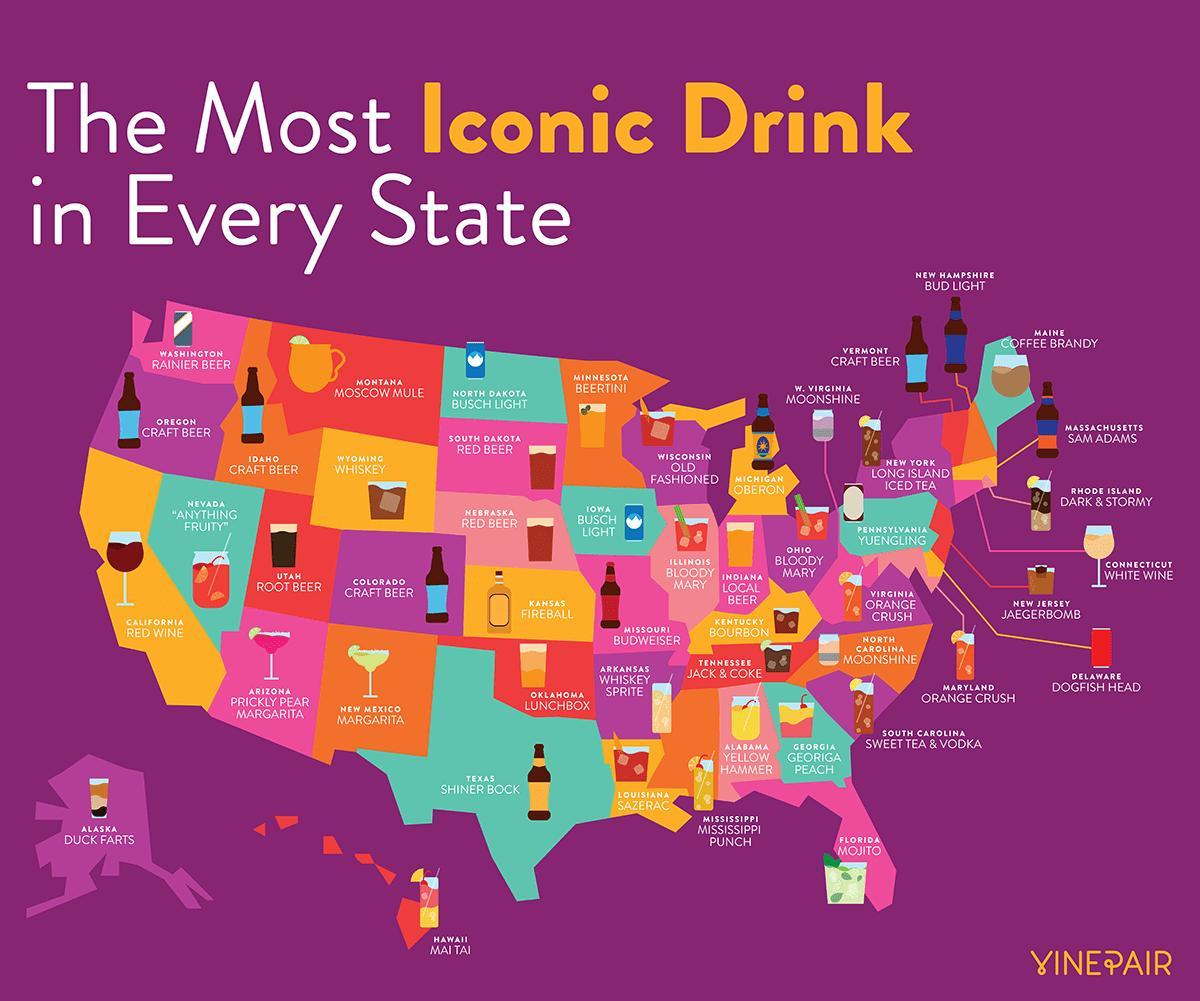How many states have craft beer as their iconic drink?
Answer the question with a short phrase. 4 Which is the iconic drink in North Dakota and Iowa? BUSCH LIGHT 